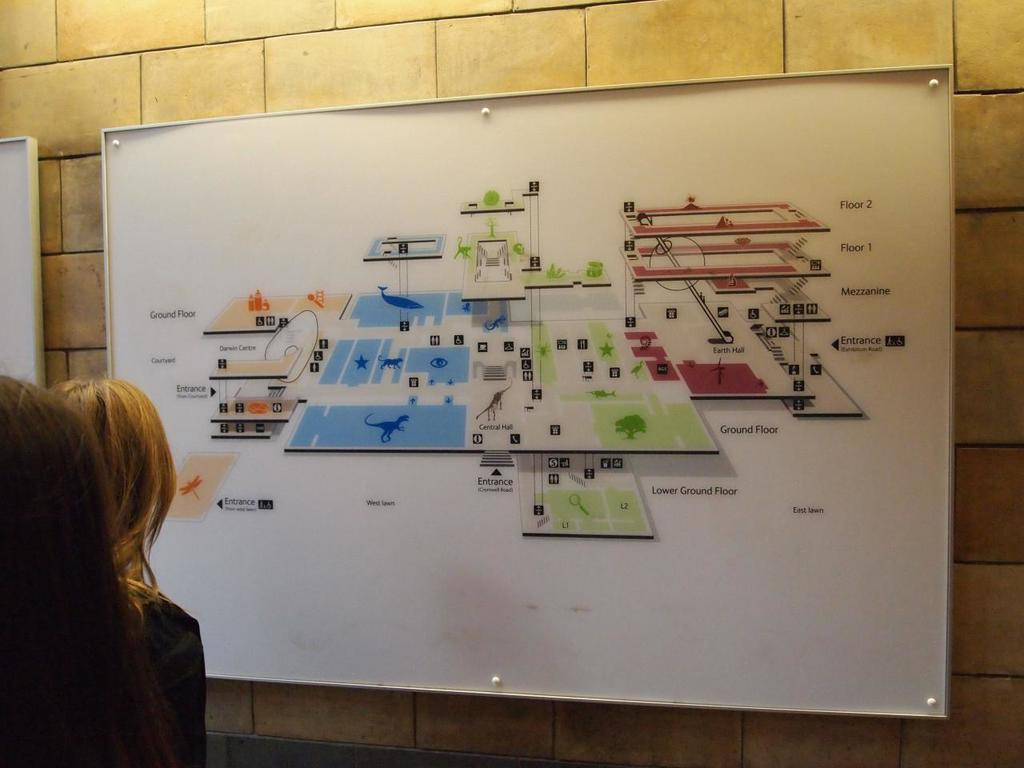What is attached to the wall in the image? There are boards on the wall in the image. How many people are present in the image? There are two people in the image. What can be seen on one of the boards? There are objects and text on one of the boards. What type of ink is used to write on the board in the image? There is no indication of ink being used on the board in the image, as the text could be written with various materials such as markers or paint. 